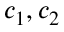Convert formula to latex. <formula><loc_0><loc_0><loc_500><loc_500>c _ { 1 } , c _ { 2 }</formula> 